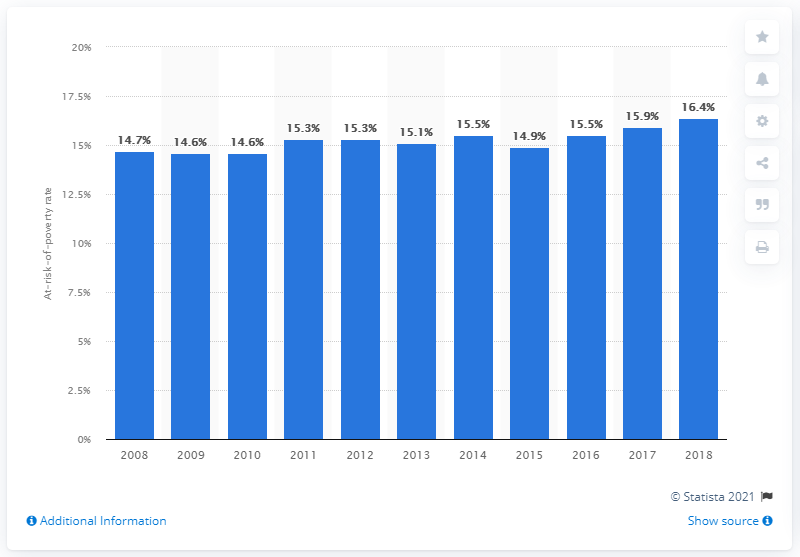List a handful of essential elements in this visual. In 2018, 15.9% of the Belgian population lived in poverty. According to data from the year 2015, approximately 15.9% of women in the United States were living below the poverty threshold. 